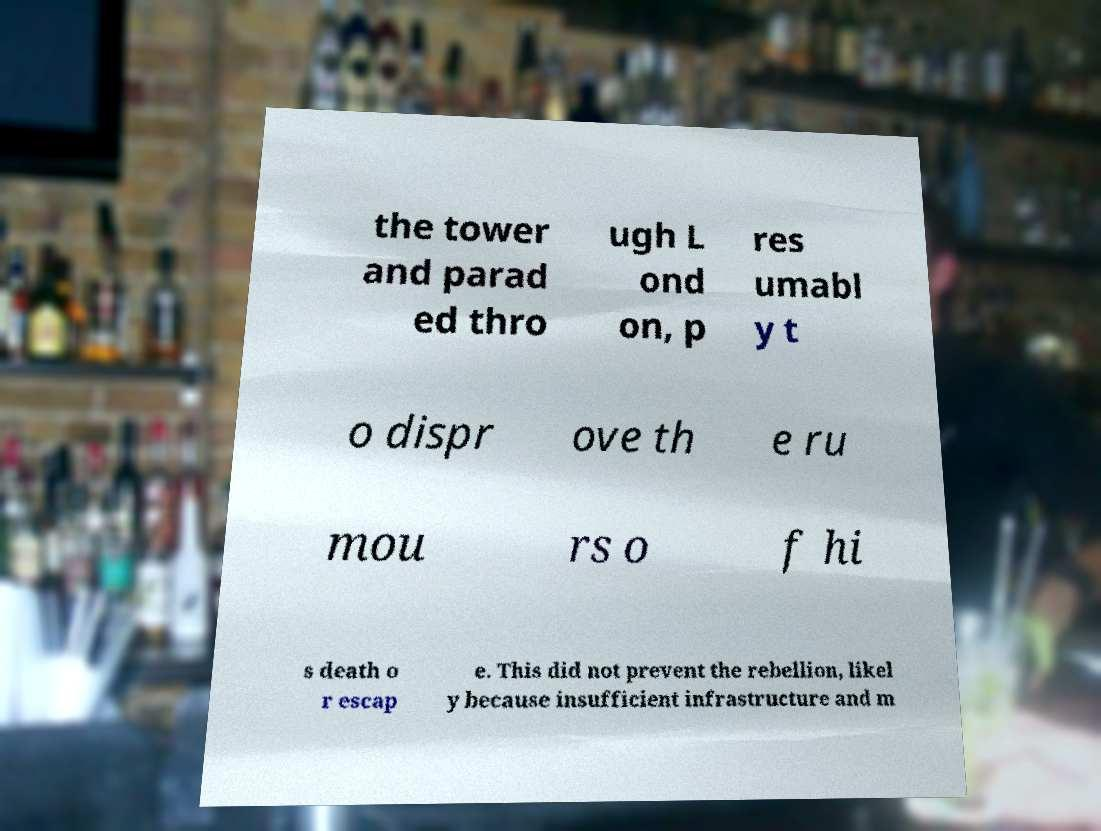Could you extract and type out the text from this image? the tower and parad ed thro ugh L ond on, p res umabl y t o dispr ove th e ru mou rs o f hi s death o r escap e. This did not prevent the rebellion, likel y because insufficient infrastructure and m 